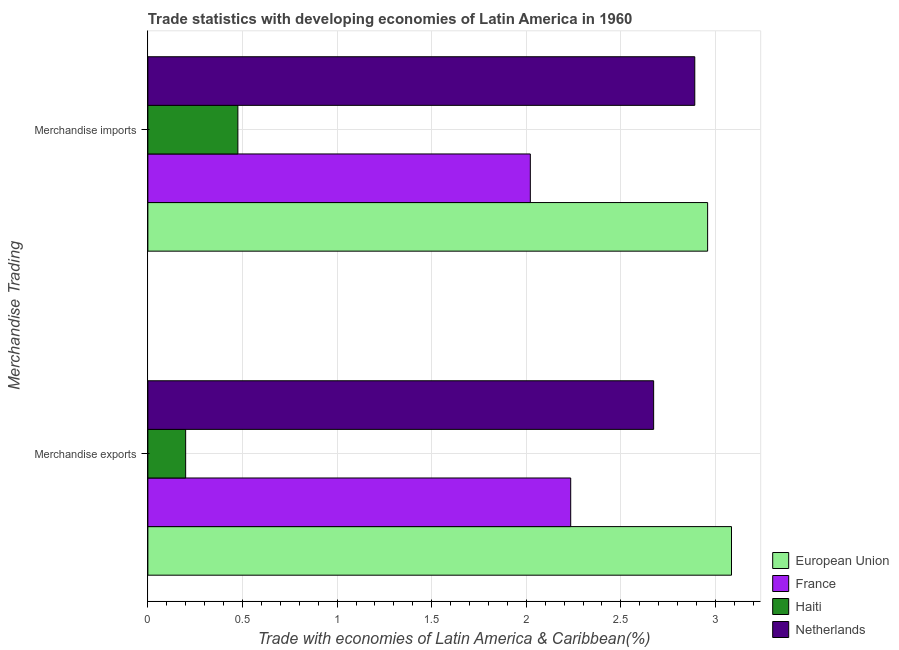How many groups of bars are there?
Offer a very short reply. 2. Are the number of bars per tick equal to the number of legend labels?
Your answer should be very brief. Yes. How many bars are there on the 1st tick from the bottom?
Your response must be concise. 4. What is the label of the 1st group of bars from the top?
Your answer should be very brief. Merchandise imports. What is the merchandise exports in European Union?
Offer a very short reply. 3.08. Across all countries, what is the maximum merchandise imports?
Your response must be concise. 2.96. Across all countries, what is the minimum merchandise imports?
Your answer should be compact. 0.48. In which country was the merchandise imports maximum?
Offer a very short reply. European Union. In which country was the merchandise imports minimum?
Offer a terse response. Haiti. What is the total merchandise imports in the graph?
Provide a succinct answer. 8.35. What is the difference between the merchandise imports in France and that in Haiti?
Offer a very short reply. 1.55. What is the difference between the merchandise imports in France and the merchandise exports in Haiti?
Provide a succinct answer. 1.82. What is the average merchandise exports per country?
Give a very brief answer. 2.05. What is the difference between the merchandise imports and merchandise exports in Netherlands?
Ensure brevity in your answer.  0.22. In how many countries, is the merchandise exports greater than 0.1 %?
Provide a succinct answer. 4. What is the ratio of the merchandise imports in Haiti to that in Netherlands?
Give a very brief answer. 0.16. In how many countries, is the merchandise imports greater than the average merchandise imports taken over all countries?
Provide a succinct answer. 2. What does the 2nd bar from the top in Merchandise imports represents?
Your response must be concise. Haiti. What does the 3rd bar from the bottom in Merchandise exports represents?
Your answer should be compact. Haiti. What is the difference between two consecutive major ticks on the X-axis?
Make the answer very short. 0.5. Are the values on the major ticks of X-axis written in scientific E-notation?
Your answer should be compact. No. Does the graph contain any zero values?
Ensure brevity in your answer.  No. Does the graph contain grids?
Your answer should be very brief. Yes. Where does the legend appear in the graph?
Make the answer very short. Bottom right. How many legend labels are there?
Give a very brief answer. 4. How are the legend labels stacked?
Your response must be concise. Vertical. What is the title of the graph?
Provide a succinct answer. Trade statistics with developing economies of Latin America in 1960. Does "Myanmar" appear as one of the legend labels in the graph?
Ensure brevity in your answer.  No. What is the label or title of the X-axis?
Ensure brevity in your answer.  Trade with economies of Latin America & Caribbean(%). What is the label or title of the Y-axis?
Your answer should be compact. Merchandise Trading. What is the Trade with economies of Latin America & Caribbean(%) of European Union in Merchandise exports?
Your response must be concise. 3.08. What is the Trade with economies of Latin America & Caribbean(%) in France in Merchandise exports?
Make the answer very short. 2.23. What is the Trade with economies of Latin America & Caribbean(%) in Haiti in Merchandise exports?
Give a very brief answer. 0.2. What is the Trade with economies of Latin America & Caribbean(%) of Netherlands in Merchandise exports?
Make the answer very short. 2.67. What is the Trade with economies of Latin America & Caribbean(%) of European Union in Merchandise imports?
Your answer should be compact. 2.96. What is the Trade with economies of Latin America & Caribbean(%) of France in Merchandise imports?
Give a very brief answer. 2.02. What is the Trade with economies of Latin America & Caribbean(%) in Haiti in Merchandise imports?
Ensure brevity in your answer.  0.48. What is the Trade with economies of Latin America & Caribbean(%) of Netherlands in Merchandise imports?
Keep it short and to the point. 2.89. Across all Merchandise Trading, what is the maximum Trade with economies of Latin America & Caribbean(%) of European Union?
Keep it short and to the point. 3.08. Across all Merchandise Trading, what is the maximum Trade with economies of Latin America & Caribbean(%) of France?
Keep it short and to the point. 2.23. Across all Merchandise Trading, what is the maximum Trade with economies of Latin America & Caribbean(%) in Haiti?
Offer a very short reply. 0.48. Across all Merchandise Trading, what is the maximum Trade with economies of Latin America & Caribbean(%) in Netherlands?
Offer a terse response. 2.89. Across all Merchandise Trading, what is the minimum Trade with economies of Latin America & Caribbean(%) of European Union?
Your answer should be very brief. 2.96. Across all Merchandise Trading, what is the minimum Trade with economies of Latin America & Caribbean(%) of France?
Your answer should be very brief. 2.02. Across all Merchandise Trading, what is the minimum Trade with economies of Latin America & Caribbean(%) in Haiti?
Your answer should be very brief. 0.2. Across all Merchandise Trading, what is the minimum Trade with economies of Latin America & Caribbean(%) in Netherlands?
Make the answer very short. 2.67. What is the total Trade with economies of Latin America & Caribbean(%) of European Union in the graph?
Keep it short and to the point. 6.04. What is the total Trade with economies of Latin America & Caribbean(%) of France in the graph?
Offer a terse response. 4.26. What is the total Trade with economies of Latin America & Caribbean(%) in Haiti in the graph?
Your answer should be compact. 0.68. What is the total Trade with economies of Latin America & Caribbean(%) of Netherlands in the graph?
Offer a very short reply. 5.56. What is the difference between the Trade with economies of Latin America & Caribbean(%) in European Union in Merchandise exports and that in Merchandise imports?
Ensure brevity in your answer.  0.13. What is the difference between the Trade with economies of Latin America & Caribbean(%) in France in Merchandise exports and that in Merchandise imports?
Offer a very short reply. 0.21. What is the difference between the Trade with economies of Latin America & Caribbean(%) of Haiti in Merchandise exports and that in Merchandise imports?
Provide a short and direct response. -0.28. What is the difference between the Trade with economies of Latin America & Caribbean(%) of Netherlands in Merchandise exports and that in Merchandise imports?
Provide a succinct answer. -0.22. What is the difference between the Trade with economies of Latin America & Caribbean(%) of European Union in Merchandise exports and the Trade with economies of Latin America & Caribbean(%) of France in Merchandise imports?
Offer a very short reply. 1.06. What is the difference between the Trade with economies of Latin America & Caribbean(%) in European Union in Merchandise exports and the Trade with economies of Latin America & Caribbean(%) in Haiti in Merchandise imports?
Your answer should be compact. 2.61. What is the difference between the Trade with economies of Latin America & Caribbean(%) in European Union in Merchandise exports and the Trade with economies of Latin America & Caribbean(%) in Netherlands in Merchandise imports?
Offer a very short reply. 0.19. What is the difference between the Trade with economies of Latin America & Caribbean(%) of France in Merchandise exports and the Trade with economies of Latin America & Caribbean(%) of Haiti in Merchandise imports?
Ensure brevity in your answer.  1.76. What is the difference between the Trade with economies of Latin America & Caribbean(%) in France in Merchandise exports and the Trade with economies of Latin America & Caribbean(%) in Netherlands in Merchandise imports?
Offer a very short reply. -0.66. What is the difference between the Trade with economies of Latin America & Caribbean(%) in Haiti in Merchandise exports and the Trade with economies of Latin America & Caribbean(%) in Netherlands in Merchandise imports?
Offer a terse response. -2.69. What is the average Trade with economies of Latin America & Caribbean(%) of European Union per Merchandise Trading?
Keep it short and to the point. 3.02. What is the average Trade with economies of Latin America & Caribbean(%) of France per Merchandise Trading?
Make the answer very short. 2.13. What is the average Trade with economies of Latin America & Caribbean(%) of Haiti per Merchandise Trading?
Provide a succinct answer. 0.34. What is the average Trade with economies of Latin America & Caribbean(%) in Netherlands per Merchandise Trading?
Make the answer very short. 2.78. What is the difference between the Trade with economies of Latin America & Caribbean(%) of European Union and Trade with economies of Latin America & Caribbean(%) of France in Merchandise exports?
Your response must be concise. 0.85. What is the difference between the Trade with economies of Latin America & Caribbean(%) of European Union and Trade with economies of Latin America & Caribbean(%) of Haiti in Merchandise exports?
Your response must be concise. 2.88. What is the difference between the Trade with economies of Latin America & Caribbean(%) of European Union and Trade with economies of Latin America & Caribbean(%) of Netherlands in Merchandise exports?
Your response must be concise. 0.41. What is the difference between the Trade with economies of Latin America & Caribbean(%) in France and Trade with economies of Latin America & Caribbean(%) in Haiti in Merchandise exports?
Your response must be concise. 2.04. What is the difference between the Trade with economies of Latin America & Caribbean(%) of France and Trade with economies of Latin America & Caribbean(%) of Netherlands in Merchandise exports?
Your answer should be compact. -0.44. What is the difference between the Trade with economies of Latin America & Caribbean(%) of Haiti and Trade with economies of Latin America & Caribbean(%) of Netherlands in Merchandise exports?
Give a very brief answer. -2.47. What is the difference between the Trade with economies of Latin America & Caribbean(%) in European Union and Trade with economies of Latin America & Caribbean(%) in France in Merchandise imports?
Your answer should be compact. 0.94. What is the difference between the Trade with economies of Latin America & Caribbean(%) in European Union and Trade with economies of Latin America & Caribbean(%) in Haiti in Merchandise imports?
Keep it short and to the point. 2.48. What is the difference between the Trade with economies of Latin America & Caribbean(%) of European Union and Trade with economies of Latin America & Caribbean(%) of Netherlands in Merchandise imports?
Offer a terse response. 0.07. What is the difference between the Trade with economies of Latin America & Caribbean(%) in France and Trade with economies of Latin America & Caribbean(%) in Haiti in Merchandise imports?
Your response must be concise. 1.55. What is the difference between the Trade with economies of Latin America & Caribbean(%) in France and Trade with economies of Latin America & Caribbean(%) in Netherlands in Merchandise imports?
Give a very brief answer. -0.87. What is the difference between the Trade with economies of Latin America & Caribbean(%) in Haiti and Trade with economies of Latin America & Caribbean(%) in Netherlands in Merchandise imports?
Your response must be concise. -2.41. What is the ratio of the Trade with economies of Latin America & Caribbean(%) of European Union in Merchandise exports to that in Merchandise imports?
Offer a terse response. 1.04. What is the ratio of the Trade with economies of Latin America & Caribbean(%) of France in Merchandise exports to that in Merchandise imports?
Keep it short and to the point. 1.11. What is the ratio of the Trade with economies of Latin America & Caribbean(%) in Haiti in Merchandise exports to that in Merchandise imports?
Offer a terse response. 0.42. What is the ratio of the Trade with economies of Latin America & Caribbean(%) of Netherlands in Merchandise exports to that in Merchandise imports?
Your answer should be very brief. 0.92. What is the difference between the highest and the second highest Trade with economies of Latin America & Caribbean(%) of European Union?
Your response must be concise. 0.13. What is the difference between the highest and the second highest Trade with economies of Latin America & Caribbean(%) of France?
Your answer should be compact. 0.21. What is the difference between the highest and the second highest Trade with economies of Latin America & Caribbean(%) of Haiti?
Your answer should be very brief. 0.28. What is the difference between the highest and the second highest Trade with economies of Latin America & Caribbean(%) of Netherlands?
Offer a very short reply. 0.22. What is the difference between the highest and the lowest Trade with economies of Latin America & Caribbean(%) in European Union?
Offer a terse response. 0.13. What is the difference between the highest and the lowest Trade with economies of Latin America & Caribbean(%) of France?
Your answer should be very brief. 0.21. What is the difference between the highest and the lowest Trade with economies of Latin America & Caribbean(%) in Haiti?
Your answer should be compact. 0.28. What is the difference between the highest and the lowest Trade with economies of Latin America & Caribbean(%) in Netherlands?
Provide a succinct answer. 0.22. 